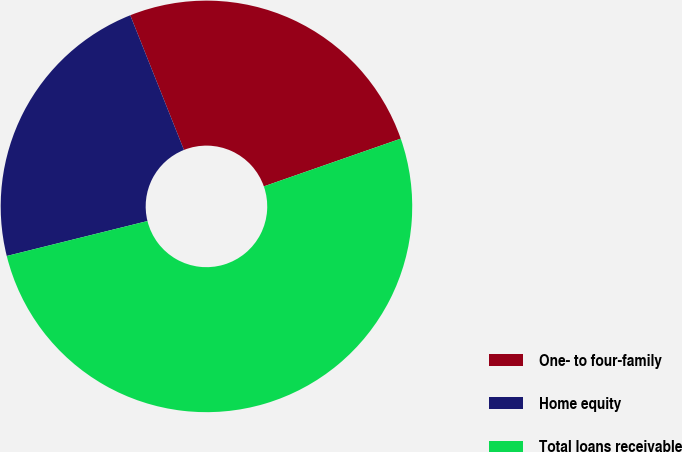Convert chart. <chart><loc_0><loc_0><loc_500><loc_500><pie_chart><fcel>One- to four-family<fcel>Home equity<fcel>Total loans receivable<nl><fcel>25.7%<fcel>22.84%<fcel>51.47%<nl></chart> 